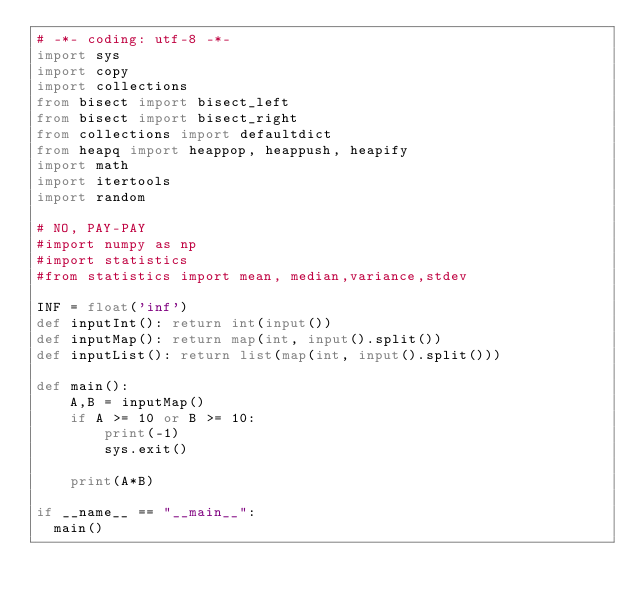Convert code to text. <code><loc_0><loc_0><loc_500><loc_500><_Python_># -*- coding: utf-8 -*-
import sys
import copy
import collections
from bisect import bisect_left
from bisect import bisect_right
from collections import defaultdict
from heapq import heappop, heappush, heapify
import math
import itertools
import random
 
# NO, PAY-PAY
#import numpy as np
#import statistics
#from statistics import mean, median,variance,stdev
 
INF = float('inf')
def inputInt(): return int(input())
def inputMap(): return map(int, input().split())
def inputList(): return list(map(int, input().split()))
 
def main():
    A,B = inputMap()
    if A >= 10 or B >= 10:
        print(-1)
        sys.exit()
        
    print(A*B)
    
if __name__ == "__main__":
	main()
</code> 